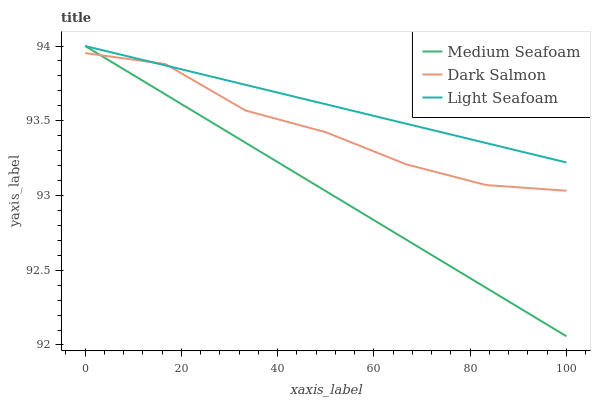Does Medium Seafoam have the minimum area under the curve?
Answer yes or no. Yes. Does Light Seafoam have the maximum area under the curve?
Answer yes or no. Yes. Does Dark Salmon have the minimum area under the curve?
Answer yes or no. No. Does Dark Salmon have the maximum area under the curve?
Answer yes or no. No. Is Medium Seafoam the smoothest?
Answer yes or no. Yes. Is Dark Salmon the roughest?
Answer yes or no. Yes. Is Dark Salmon the smoothest?
Answer yes or no. No. Is Medium Seafoam the roughest?
Answer yes or no. No. Does Medium Seafoam have the lowest value?
Answer yes or no. Yes. Does Dark Salmon have the lowest value?
Answer yes or no. No. Does Medium Seafoam have the highest value?
Answer yes or no. Yes. Does Dark Salmon have the highest value?
Answer yes or no. No. Does Medium Seafoam intersect Dark Salmon?
Answer yes or no. Yes. Is Medium Seafoam less than Dark Salmon?
Answer yes or no. No. Is Medium Seafoam greater than Dark Salmon?
Answer yes or no. No. 